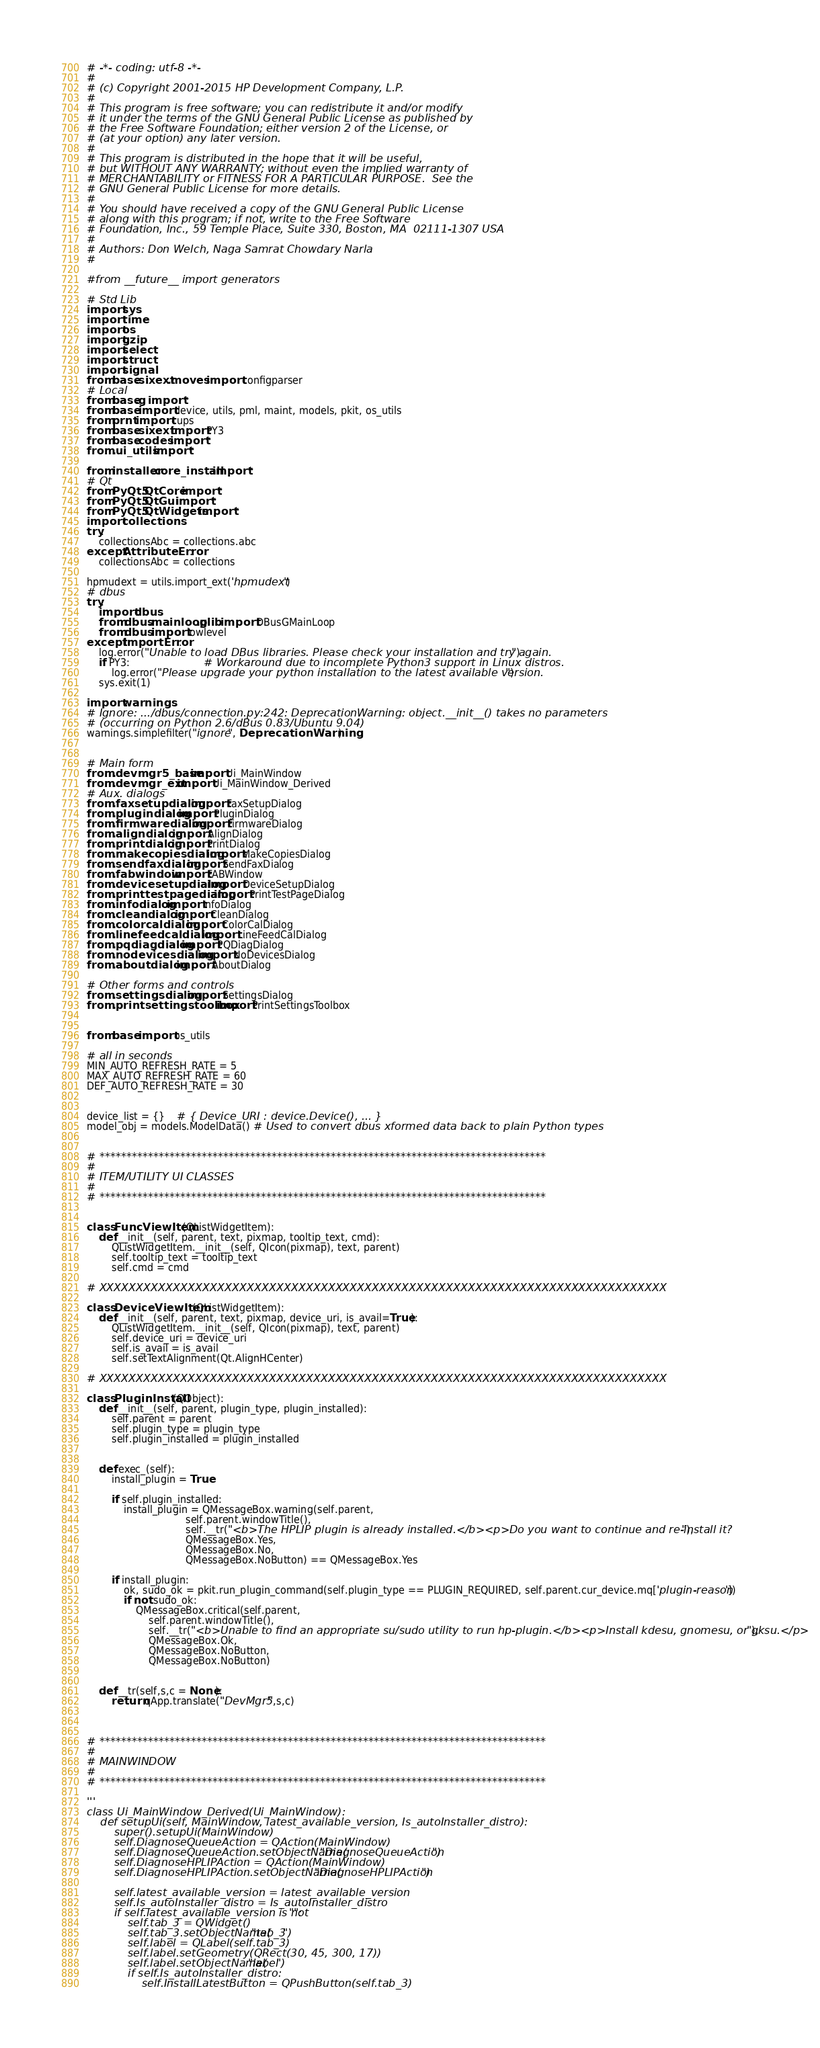Convert code to text. <code><loc_0><loc_0><loc_500><loc_500><_Python_># -*- coding: utf-8 -*-
#
# (c) Copyright 2001-2015 HP Development Company, L.P.
#
# This program is free software; you can redistribute it and/or modify
# it under the terms of the GNU General Public License as published by
# the Free Software Foundation; either version 2 of the License, or
# (at your option) any later version.
#
# This program is distributed in the hope that it will be useful,
# but WITHOUT ANY WARRANTY; without even the implied warranty of
# MERCHANTABILITY or FITNESS FOR A PARTICULAR PURPOSE.  See the
# GNU General Public License for more details.
#
# You should have received a copy of the GNU General Public License
# along with this program; if not, write to the Free Software
# Foundation, Inc., 59 Temple Place, Suite 330, Boston, MA  02111-1307 USA
#
# Authors: Don Welch, Naga Samrat Chowdary Narla
#

#from __future__ import generators

# Std Lib
import sys
import time
import os
import gzip
import select
import struct
import signal
from base.sixext.moves import configparser
# Local
from base.g import *
from base import device, utils, pml, maint, models, pkit, os_utils
from prnt import cups
from base.sixext import PY3
from base.codes import *
from .ui_utils import *

from installer.core_install import *
# Qt
from PyQt5.QtCore import *
from PyQt5.QtGui import *
from PyQt5.QtWidgets import *
import collections
try:
    collectionsAbc = collections.abc
except AttributeError:
    collectionsAbc = collections

hpmudext = utils.import_ext('hpmudext')
# dbus
try:
    import dbus
    from dbus.mainloop.glib import DBusGMainLoop
    from dbus import lowlevel
except ImportError:
    log.error("Unable to load DBus libraries. Please check your installation and try again.")
    if PY3:                        # Workaround due to incomplete Python3 support in Linux distros.
        log.error("Please upgrade your python installation to the latest available version.")
    sys.exit(1)

import warnings
# Ignore: .../dbus/connection.py:242: DeprecationWarning: object.__init__() takes no parameters
# (occurring on Python 2.6/dBus 0.83/Ubuntu 9.04)
warnings.simplefilter("ignore", DeprecationWarning)


# Main form
from .devmgr5_base import Ui_MainWindow
from .devmgr_ext import Ui_MainWindow_Derived
# Aux. dialogs
from .faxsetupdialog import FaxSetupDialog
from .plugindialog import PluginDialog
from .firmwaredialog import FirmwareDialog
from .aligndialog import AlignDialog
from .printdialog import PrintDialog
from .makecopiesdialog import MakeCopiesDialog
from .sendfaxdialog import SendFaxDialog
from .fabwindow import FABWindow
from .devicesetupdialog import DeviceSetupDialog
from .printtestpagedialog import PrintTestPageDialog
from .infodialog import InfoDialog
from .cleandialog import CleanDialog
from .colorcaldialog import ColorCalDialog
from .linefeedcaldialog import LineFeedCalDialog
from .pqdiagdialog import PQDiagDialog
from .nodevicesdialog import NoDevicesDialog
from .aboutdialog import AboutDialog

# Other forms and controls
from .settingsdialog import SettingsDialog
from .printsettingstoolbox import PrintSettingsToolbox


from base import os_utils

# all in seconds
MIN_AUTO_REFRESH_RATE = 5
MAX_AUTO_REFRESH_RATE = 60
DEF_AUTO_REFRESH_RATE = 30


device_list = {}    # { Device_URI : device.Device(), ... }
model_obj = models.ModelData() # Used to convert dbus xformed data back to plain Python types


# ***********************************************************************************
#
# ITEM/UTILITY UI CLASSES
#
# ***********************************************************************************


class FuncViewItem(QListWidgetItem):
    def __init__(self, parent, text, pixmap, tooltip_text, cmd):
        QListWidgetItem.__init__(self, QIcon(pixmap), text, parent)
        self.tooltip_text = tooltip_text
        self.cmd = cmd

# XXXXXXXXXXXXXXXXXXXXXXXXXXXXXXXXXXXXXXXXXXXXXXXXXXXXXXXXXXXXXXXXXXXXXXXXXXXXX

class DeviceViewItem(QListWidgetItem):
    def __init__(self, parent, text, pixmap, device_uri, is_avail=True):
        QListWidgetItem.__init__(self, QIcon(pixmap), text, parent)
        self.device_uri = device_uri
        self.is_avail = is_avail
        self.setTextAlignment(Qt.AlignHCenter)

# XXXXXXXXXXXXXXXXXXXXXXXXXXXXXXXXXXXXXXXXXXXXXXXXXXXXXXXXXXXXXXXXXXXXXXXXXXXXX

class PluginInstall(QObject):
    def __init__(self, parent, plugin_type, plugin_installed):
        self.parent = parent
        self.plugin_type = plugin_type
        self.plugin_installed = plugin_installed


    def exec_(self):
        install_plugin = True

        if self.plugin_installed:
            install_plugin = QMessageBox.warning(self.parent,
                                self.parent.windowTitle(),
                                self.__tr("<b>The HPLIP plugin is already installed.</b><p>Do you want to continue and re-install it?"),
                                QMessageBox.Yes,
                                QMessageBox.No,
                                QMessageBox.NoButton) == QMessageBox.Yes

        if install_plugin:
            ok, sudo_ok = pkit.run_plugin_command(self.plugin_type == PLUGIN_REQUIRED, self.parent.cur_device.mq['plugin-reason'])
            if not sudo_ok:
                QMessageBox.critical(self.parent,
                    self.parent.windowTitle(),
                    self.__tr("<b>Unable to find an appropriate su/sudo utility to run hp-plugin.</b><p>Install kdesu, gnomesu, or gksu.</p>"),
                    QMessageBox.Ok,
                    QMessageBox.NoButton,
                    QMessageBox.NoButton)


    def __tr(self,s,c = None):
        return qApp.translate("DevMgr5",s,c)



# ***********************************************************************************
#
# MAINWINDOW
#
# ***********************************************************************************

'''
class Ui_MainWindow_Derived(Ui_MainWindow):
    def setupUi(self, MainWindow, latest_available_version, Is_autoInstaller_distro):
        super().setupUi(MainWindow)
        self.DiagnoseQueueAction = QAction(MainWindow)
        self.DiagnoseQueueAction.setObjectName("DiagnoseQueueAction")
        self.DiagnoseHPLIPAction = QAction(MainWindow)
        self.DiagnoseHPLIPAction.setObjectName("DiagnoseHPLIPAction")
        
        self.latest_available_version = latest_available_version
        self.Is_autoInstaller_distro = Is_autoInstaller_distro
        if self.latest_available_version is not "":
            self.tab_3 = QWidget()
            self.tab_3.setObjectName("tab_3")
            self.label = QLabel(self.tab_3)
            self.label.setGeometry(QRect(30, 45, 300, 17))
            self.label.setObjectName("label")
            if self.Is_autoInstaller_distro:
                self.InstallLatestButton = QPushButton(self.tab_3)</code> 